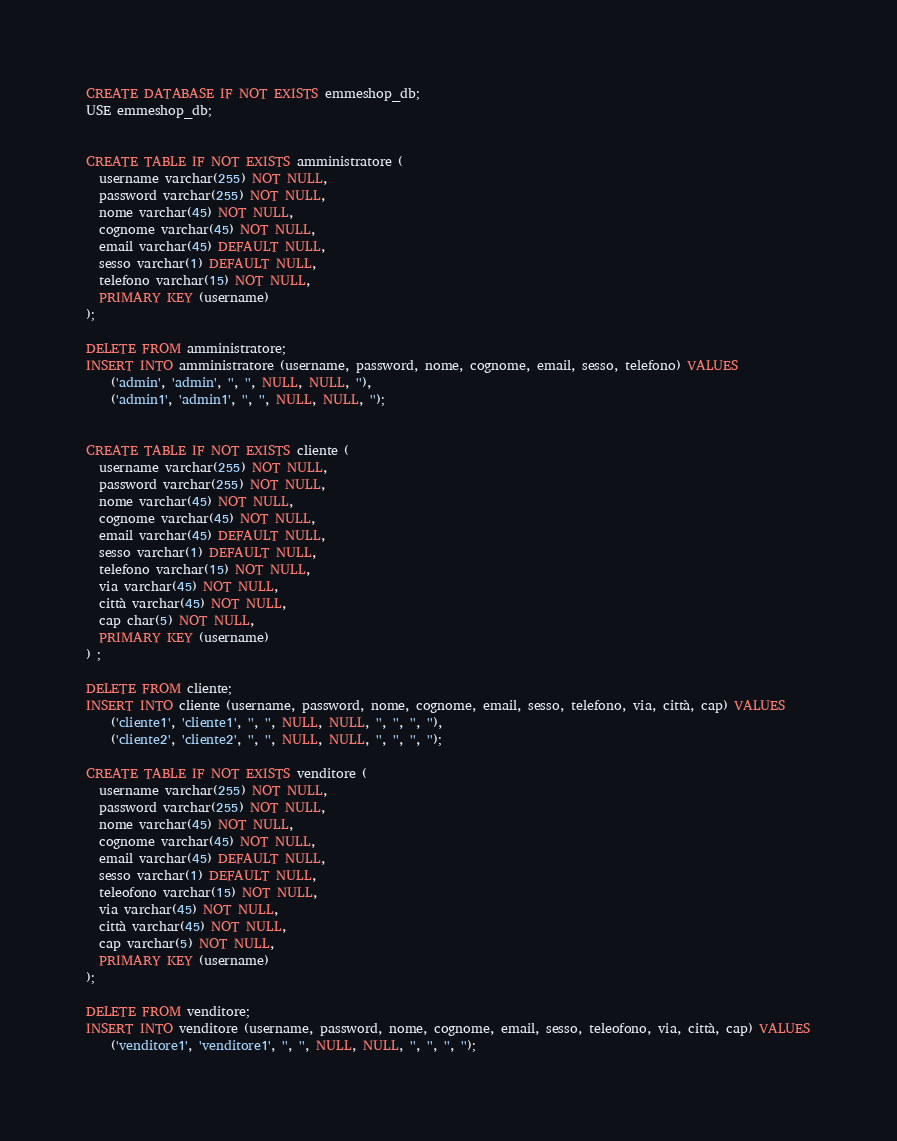Convert code to text. <code><loc_0><loc_0><loc_500><loc_500><_SQL_>
CREATE DATABASE IF NOT EXISTS emmeshop_db; 
USE emmeshop_db;


CREATE TABLE IF NOT EXISTS amministratore (
  username varchar(255) NOT NULL,
  password varchar(255) NOT NULL,
  nome varchar(45) NOT NULL,
  cognome varchar(45) NOT NULL,
  email varchar(45) DEFAULT NULL,
  sesso varchar(1) DEFAULT NULL,
  telefono varchar(15) NOT NULL,
  PRIMARY KEY (username)
);

DELETE FROM amministratore;
INSERT INTO amministratore (username, password, nome, cognome, email, sesso, telefono) VALUES
	('admin', 'admin', '', '', NULL, NULL, ''),
	('admin1', 'admin1', '', '', NULL, NULL, '');


CREATE TABLE IF NOT EXISTS cliente (
  username varchar(255) NOT NULL,
  password varchar(255) NOT NULL,
  nome varchar(45) NOT NULL,
  cognome varchar(45) NOT NULL,
  email varchar(45) DEFAULT NULL,
  sesso varchar(1) DEFAULT NULL,
  telefono varchar(15) NOT NULL,
  via varchar(45) NOT NULL,
  città varchar(45) NOT NULL,
  cap char(5) NOT NULL,
  PRIMARY KEY (username)
) ;

DELETE FROM cliente;
INSERT INTO cliente (username, password, nome, cognome, email, sesso, telefono, via, città, cap) VALUES
	('cliente1', 'cliente1', '', '', NULL, NULL, '', '', '', ''),
	('cliente2', 'cliente2', '', '', NULL, NULL, '', '', '', '');

CREATE TABLE IF NOT EXISTS venditore (
  username varchar(255) NOT NULL,
  password varchar(255) NOT NULL,
  nome varchar(45) NOT NULL,
  cognome varchar(45) NOT NULL,
  email varchar(45) DEFAULT NULL,
  sesso varchar(1) DEFAULT NULL,
  teleofono varchar(15) NOT NULL,
  via varchar(45) NOT NULL,
  città varchar(45) NOT NULL,
  cap varchar(5) NOT NULL,
  PRIMARY KEY (username)
);

DELETE FROM venditore;
INSERT INTO venditore (username, password, nome, cognome, email, sesso, teleofono, via, città, cap) VALUES
	('venditore1', 'venditore1', '', '', NULL, NULL, '', '', '', '');

</code> 